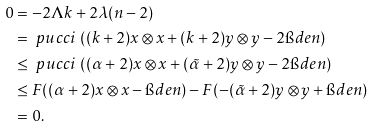Convert formula to latex. <formula><loc_0><loc_0><loc_500><loc_500>0 & = - 2 \Lambda k + 2 \lambda ( n - 2 ) \\ & = \ p u c c i \, \left ( ( k + 2 ) x \otimes x + ( k + 2 ) y \otimes y - 2 \i d e n \right ) \\ & \leq \ p u c c i \, \left ( ( \alpha + 2 ) x \otimes x + ( \tilde { \alpha } + 2 ) y \otimes y - 2 \i d e n \right ) \\ & \leq F ( ( \alpha + 2 ) x \otimes x - \i d e n ) - F ( - ( \tilde { \alpha } + 2 ) y \otimes y + \i d e n ) \\ & = 0 .</formula> 